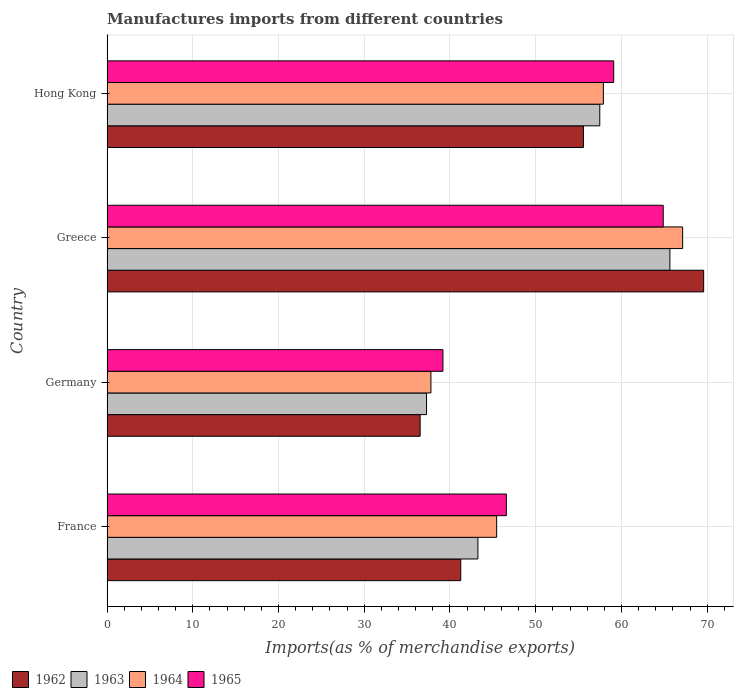How many groups of bars are there?
Make the answer very short. 4. Are the number of bars per tick equal to the number of legend labels?
Make the answer very short. Yes. How many bars are there on the 1st tick from the top?
Give a very brief answer. 4. What is the label of the 4th group of bars from the top?
Make the answer very short. France. What is the percentage of imports to different countries in 1963 in Greece?
Your answer should be very brief. 65.65. Across all countries, what is the maximum percentage of imports to different countries in 1962?
Offer a terse response. 69.58. Across all countries, what is the minimum percentage of imports to different countries in 1963?
Your answer should be very brief. 37.26. In which country was the percentage of imports to different countries in 1965 maximum?
Your response must be concise. Greece. In which country was the percentage of imports to different countries in 1965 minimum?
Your answer should be compact. Germany. What is the total percentage of imports to different countries in 1962 in the graph?
Ensure brevity in your answer.  202.92. What is the difference between the percentage of imports to different countries in 1962 in Greece and that in Hong Kong?
Offer a terse response. 14.02. What is the difference between the percentage of imports to different countries in 1962 in Greece and the percentage of imports to different countries in 1964 in France?
Make the answer very short. 24.14. What is the average percentage of imports to different countries in 1965 per country?
Provide a short and direct response. 52.43. What is the difference between the percentage of imports to different countries in 1965 and percentage of imports to different countries in 1964 in Germany?
Keep it short and to the point. 1.4. In how many countries, is the percentage of imports to different countries in 1962 greater than 2 %?
Your answer should be very brief. 4. What is the ratio of the percentage of imports to different countries in 1965 in Greece to that in Hong Kong?
Your answer should be very brief. 1.1. Is the difference between the percentage of imports to different countries in 1965 in Germany and Hong Kong greater than the difference between the percentage of imports to different countries in 1964 in Germany and Hong Kong?
Ensure brevity in your answer.  Yes. What is the difference between the highest and the second highest percentage of imports to different countries in 1963?
Give a very brief answer. 8.18. What is the difference between the highest and the lowest percentage of imports to different countries in 1964?
Your response must be concise. 29.35. In how many countries, is the percentage of imports to different countries in 1962 greater than the average percentage of imports to different countries in 1962 taken over all countries?
Your answer should be compact. 2. Is the sum of the percentage of imports to different countries in 1965 in Greece and Hong Kong greater than the maximum percentage of imports to different countries in 1962 across all countries?
Offer a very short reply. Yes. Is it the case that in every country, the sum of the percentage of imports to different countries in 1965 and percentage of imports to different countries in 1963 is greater than the sum of percentage of imports to different countries in 1964 and percentage of imports to different countries in 1962?
Provide a short and direct response. No. What does the 2nd bar from the top in Germany represents?
Make the answer very short. 1964. What does the 3rd bar from the bottom in Hong Kong represents?
Your response must be concise. 1964. Is it the case that in every country, the sum of the percentage of imports to different countries in 1965 and percentage of imports to different countries in 1963 is greater than the percentage of imports to different countries in 1964?
Your answer should be compact. Yes. How many countries are there in the graph?
Your answer should be compact. 4. What is the difference between two consecutive major ticks on the X-axis?
Provide a succinct answer. 10. Does the graph contain any zero values?
Ensure brevity in your answer.  No. Does the graph contain grids?
Your answer should be very brief. Yes. Where does the legend appear in the graph?
Keep it short and to the point. Bottom left. How many legend labels are there?
Ensure brevity in your answer.  4. How are the legend labels stacked?
Make the answer very short. Horizontal. What is the title of the graph?
Provide a succinct answer. Manufactures imports from different countries. What is the label or title of the X-axis?
Your answer should be very brief. Imports(as % of merchandise exports). What is the label or title of the Y-axis?
Provide a succinct answer. Country. What is the Imports(as % of merchandise exports) in 1962 in France?
Give a very brief answer. 41.26. What is the Imports(as % of merchandise exports) of 1963 in France?
Give a very brief answer. 43.26. What is the Imports(as % of merchandise exports) of 1964 in France?
Offer a very short reply. 45.44. What is the Imports(as % of merchandise exports) in 1965 in France?
Your answer should be compact. 46.57. What is the Imports(as % of merchandise exports) in 1962 in Germany?
Your answer should be compact. 36.52. What is the Imports(as % of merchandise exports) of 1963 in Germany?
Your answer should be very brief. 37.26. What is the Imports(as % of merchandise exports) in 1964 in Germany?
Your answer should be very brief. 37.78. What is the Imports(as % of merchandise exports) of 1965 in Germany?
Offer a terse response. 39.18. What is the Imports(as % of merchandise exports) in 1962 in Greece?
Offer a very short reply. 69.58. What is the Imports(as % of merchandise exports) of 1963 in Greece?
Keep it short and to the point. 65.65. What is the Imports(as % of merchandise exports) of 1964 in Greece?
Make the answer very short. 67.13. What is the Imports(as % of merchandise exports) in 1965 in Greece?
Your response must be concise. 64.87. What is the Imports(as % of merchandise exports) of 1962 in Hong Kong?
Your response must be concise. 55.56. What is the Imports(as % of merchandise exports) in 1963 in Hong Kong?
Ensure brevity in your answer.  57.47. What is the Imports(as % of merchandise exports) in 1964 in Hong Kong?
Your answer should be very brief. 57.89. What is the Imports(as % of merchandise exports) in 1965 in Hong Kong?
Your answer should be compact. 59.09. Across all countries, what is the maximum Imports(as % of merchandise exports) of 1962?
Provide a succinct answer. 69.58. Across all countries, what is the maximum Imports(as % of merchandise exports) in 1963?
Provide a short and direct response. 65.65. Across all countries, what is the maximum Imports(as % of merchandise exports) in 1964?
Give a very brief answer. 67.13. Across all countries, what is the maximum Imports(as % of merchandise exports) of 1965?
Give a very brief answer. 64.87. Across all countries, what is the minimum Imports(as % of merchandise exports) of 1962?
Your response must be concise. 36.52. Across all countries, what is the minimum Imports(as % of merchandise exports) in 1963?
Your answer should be compact. 37.26. Across all countries, what is the minimum Imports(as % of merchandise exports) of 1964?
Keep it short and to the point. 37.78. Across all countries, what is the minimum Imports(as % of merchandise exports) in 1965?
Make the answer very short. 39.18. What is the total Imports(as % of merchandise exports) in 1962 in the graph?
Offer a very short reply. 202.92. What is the total Imports(as % of merchandise exports) in 1963 in the graph?
Make the answer very short. 203.63. What is the total Imports(as % of merchandise exports) of 1964 in the graph?
Provide a succinct answer. 208.24. What is the total Imports(as % of merchandise exports) in 1965 in the graph?
Provide a short and direct response. 209.71. What is the difference between the Imports(as % of merchandise exports) in 1962 in France and that in Germany?
Your answer should be compact. 4.74. What is the difference between the Imports(as % of merchandise exports) of 1963 in France and that in Germany?
Provide a succinct answer. 5.99. What is the difference between the Imports(as % of merchandise exports) in 1964 in France and that in Germany?
Offer a very short reply. 7.67. What is the difference between the Imports(as % of merchandise exports) in 1965 in France and that in Germany?
Your answer should be very brief. 7.4. What is the difference between the Imports(as % of merchandise exports) of 1962 in France and that in Greece?
Make the answer very short. -28.33. What is the difference between the Imports(as % of merchandise exports) in 1963 in France and that in Greece?
Make the answer very short. -22.39. What is the difference between the Imports(as % of merchandise exports) of 1964 in France and that in Greece?
Provide a short and direct response. -21.69. What is the difference between the Imports(as % of merchandise exports) of 1965 in France and that in Greece?
Give a very brief answer. -18.29. What is the difference between the Imports(as % of merchandise exports) in 1962 in France and that in Hong Kong?
Your response must be concise. -14.31. What is the difference between the Imports(as % of merchandise exports) of 1963 in France and that in Hong Kong?
Provide a short and direct response. -14.21. What is the difference between the Imports(as % of merchandise exports) of 1964 in France and that in Hong Kong?
Your answer should be compact. -12.45. What is the difference between the Imports(as % of merchandise exports) in 1965 in France and that in Hong Kong?
Keep it short and to the point. -12.52. What is the difference between the Imports(as % of merchandise exports) of 1962 in Germany and that in Greece?
Make the answer very short. -33.06. What is the difference between the Imports(as % of merchandise exports) of 1963 in Germany and that in Greece?
Your response must be concise. -28.38. What is the difference between the Imports(as % of merchandise exports) in 1964 in Germany and that in Greece?
Provide a succinct answer. -29.35. What is the difference between the Imports(as % of merchandise exports) in 1965 in Germany and that in Greece?
Offer a very short reply. -25.69. What is the difference between the Imports(as % of merchandise exports) of 1962 in Germany and that in Hong Kong?
Provide a short and direct response. -19.04. What is the difference between the Imports(as % of merchandise exports) of 1963 in Germany and that in Hong Kong?
Give a very brief answer. -20.2. What is the difference between the Imports(as % of merchandise exports) of 1964 in Germany and that in Hong Kong?
Offer a terse response. -20.11. What is the difference between the Imports(as % of merchandise exports) of 1965 in Germany and that in Hong Kong?
Your response must be concise. -19.91. What is the difference between the Imports(as % of merchandise exports) in 1962 in Greece and that in Hong Kong?
Offer a very short reply. 14.02. What is the difference between the Imports(as % of merchandise exports) of 1963 in Greece and that in Hong Kong?
Keep it short and to the point. 8.18. What is the difference between the Imports(as % of merchandise exports) in 1964 in Greece and that in Hong Kong?
Offer a terse response. 9.24. What is the difference between the Imports(as % of merchandise exports) in 1965 in Greece and that in Hong Kong?
Offer a terse response. 5.78. What is the difference between the Imports(as % of merchandise exports) of 1962 in France and the Imports(as % of merchandise exports) of 1963 in Germany?
Provide a succinct answer. 3.99. What is the difference between the Imports(as % of merchandise exports) in 1962 in France and the Imports(as % of merchandise exports) in 1964 in Germany?
Keep it short and to the point. 3.48. What is the difference between the Imports(as % of merchandise exports) of 1962 in France and the Imports(as % of merchandise exports) of 1965 in Germany?
Provide a short and direct response. 2.08. What is the difference between the Imports(as % of merchandise exports) in 1963 in France and the Imports(as % of merchandise exports) in 1964 in Germany?
Offer a very short reply. 5.48. What is the difference between the Imports(as % of merchandise exports) of 1963 in France and the Imports(as % of merchandise exports) of 1965 in Germany?
Provide a short and direct response. 4.08. What is the difference between the Imports(as % of merchandise exports) in 1964 in France and the Imports(as % of merchandise exports) in 1965 in Germany?
Provide a short and direct response. 6.27. What is the difference between the Imports(as % of merchandise exports) of 1962 in France and the Imports(as % of merchandise exports) of 1963 in Greece?
Provide a succinct answer. -24.39. What is the difference between the Imports(as % of merchandise exports) of 1962 in France and the Imports(as % of merchandise exports) of 1964 in Greece?
Make the answer very short. -25.87. What is the difference between the Imports(as % of merchandise exports) in 1962 in France and the Imports(as % of merchandise exports) in 1965 in Greece?
Keep it short and to the point. -23.61. What is the difference between the Imports(as % of merchandise exports) of 1963 in France and the Imports(as % of merchandise exports) of 1964 in Greece?
Provide a short and direct response. -23.87. What is the difference between the Imports(as % of merchandise exports) of 1963 in France and the Imports(as % of merchandise exports) of 1965 in Greece?
Keep it short and to the point. -21.61. What is the difference between the Imports(as % of merchandise exports) in 1964 in France and the Imports(as % of merchandise exports) in 1965 in Greece?
Keep it short and to the point. -19.43. What is the difference between the Imports(as % of merchandise exports) of 1962 in France and the Imports(as % of merchandise exports) of 1963 in Hong Kong?
Your answer should be very brief. -16.21. What is the difference between the Imports(as % of merchandise exports) of 1962 in France and the Imports(as % of merchandise exports) of 1964 in Hong Kong?
Offer a terse response. -16.63. What is the difference between the Imports(as % of merchandise exports) in 1962 in France and the Imports(as % of merchandise exports) in 1965 in Hong Kong?
Your answer should be very brief. -17.83. What is the difference between the Imports(as % of merchandise exports) in 1963 in France and the Imports(as % of merchandise exports) in 1964 in Hong Kong?
Your answer should be very brief. -14.63. What is the difference between the Imports(as % of merchandise exports) of 1963 in France and the Imports(as % of merchandise exports) of 1965 in Hong Kong?
Ensure brevity in your answer.  -15.83. What is the difference between the Imports(as % of merchandise exports) of 1964 in France and the Imports(as % of merchandise exports) of 1965 in Hong Kong?
Make the answer very short. -13.65. What is the difference between the Imports(as % of merchandise exports) of 1962 in Germany and the Imports(as % of merchandise exports) of 1963 in Greece?
Keep it short and to the point. -29.13. What is the difference between the Imports(as % of merchandise exports) in 1962 in Germany and the Imports(as % of merchandise exports) in 1964 in Greece?
Your answer should be compact. -30.61. What is the difference between the Imports(as % of merchandise exports) of 1962 in Germany and the Imports(as % of merchandise exports) of 1965 in Greece?
Your response must be concise. -28.35. What is the difference between the Imports(as % of merchandise exports) in 1963 in Germany and the Imports(as % of merchandise exports) in 1964 in Greece?
Make the answer very short. -29.87. What is the difference between the Imports(as % of merchandise exports) in 1963 in Germany and the Imports(as % of merchandise exports) in 1965 in Greece?
Make the answer very short. -27.6. What is the difference between the Imports(as % of merchandise exports) in 1964 in Germany and the Imports(as % of merchandise exports) in 1965 in Greece?
Provide a succinct answer. -27.09. What is the difference between the Imports(as % of merchandise exports) in 1962 in Germany and the Imports(as % of merchandise exports) in 1963 in Hong Kong?
Your response must be concise. -20.95. What is the difference between the Imports(as % of merchandise exports) in 1962 in Germany and the Imports(as % of merchandise exports) in 1964 in Hong Kong?
Make the answer very short. -21.37. What is the difference between the Imports(as % of merchandise exports) of 1962 in Germany and the Imports(as % of merchandise exports) of 1965 in Hong Kong?
Keep it short and to the point. -22.57. What is the difference between the Imports(as % of merchandise exports) of 1963 in Germany and the Imports(as % of merchandise exports) of 1964 in Hong Kong?
Your response must be concise. -20.62. What is the difference between the Imports(as % of merchandise exports) of 1963 in Germany and the Imports(as % of merchandise exports) of 1965 in Hong Kong?
Provide a short and direct response. -21.83. What is the difference between the Imports(as % of merchandise exports) of 1964 in Germany and the Imports(as % of merchandise exports) of 1965 in Hong Kong?
Provide a succinct answer. -21.31. What is the difference between the Imports(as % of merchandise exports) of 1962 in Greece and the Imports(as % of merchandise exports) of 1963 in Hong Kong?
Your answer should be very brief. 12.12. What is the difference between the Imports(as % of merchandise exports) in 1962 in Greece and the Imports(as % of merchandise exports) in 1964 in Hong Kong?
Provide a succinct answer. 11.7. What is the difference between the Imports(as % of merchandise exports) in 1962 in Greece and the Imports(as % of merchandise exports) in 1965 in Hong Kong?
Provide a succinct answer. 10.49. What is the difference between the Imports(as % of merchandise exports) in 1963 in Greece and the Imports(as % of merchandise exports) in 1964 in Hong Kong?
Your response must be concise. 7.76. What is the difference between the Imports(as % of merchandise exports) in 1963 in Greece and the Imports(as % of merchandise exports) in 1965 in Hong Kong?
Your answer should be compact. 6.56. What is the difference between the Imports(as % of merchandise exports) in 1964 in Greece and the Imports(as % of merchandise exports) in 1965 in Hong Kong?
Make the answer very short. 8.04. What is the average Imports(as % of merchandise exports) of 1962 per country?
Give a very brief answer. 50.73. What is the average Imports(as % of merchandise exports) of 1963 per country?
Make the answer very short. 50.91. What is the average Imports(as % of merchandise exports) of 1964 per country?
Your response must be concise. 52.06. What is the average Imports(as % of merchandise exports) of 1965 per country?
Your response must be concise. 52.43. What is the difference between the Imports(as % of merchandise exports) in 1962 and Imports(as % of merchandise exports) in 1963 in France?
Keep it short and to the point. -2. What is the difference between the Imports(as % of merchandise exports) in 1962 and Imports(as % of merchandise exports) in 1964 in France?
Your answer should be compact. -4.19. What is the difference between the Imports(as % of merchandise exports) in 1962 and Imports(as % of merchandise exports) in 1965 in France?
Your response must be concise. -5.32. What is the difference between the Imports(as % of merchandise exports) in 1963 and Imports(as % of merchandise exports) in 1964 in France?
Ensure brevity in your answer.  -2.19. What is the difference between the Imports(as % of merchandise exports) in 1963 and Imports(as % of merchandise exports) in 1965 in France?
Offer a terse response. -3.32. What is the difference between the Imports(as % of merchandise exports) of 1964 and Imports(as % of merchandise exports) of 1965 in France?
Keep it short and to the point. -1.13. What is the difference between the Imports(as % of merchandise exports) of 1962 and Imports(as % of merchandise exports) of 1963 in Germany?
Provide a succinct answer. -0.75. What is the difference between the Imports(as % of merchandise exports) of 1962 and Imports(as % of merchandise exports) of 1964 in Germany?
Offer a very short reply. -1.26. What is the difference between the Imports(as % of merchandise exports) in 1962 and Imports(as % of merchandise exports) in 1965 in Germany?
Your answer should be compact. -2.66. What is the difference between the Imports(as % of merchandise exports) in 1963 and Imports(as % of merchandise exports) in 1964 in Germany?
Give a very brief answer. -0.51. What is the difference between the Imports(as % of merchandise exports) in 1963 and Imports(as % of merchandise exports) in 1965 in Germany?
Offer a very short reply. -1.91. What is the difference between the Imports(as % of merchandise exports) of 1964 and Imports(as % of merchandise exports) of 1965 in Germany?
Provide a succinct answer. -1.4. What is the difference between the Imports(as % of merchandise exports) of 1962 and Imports(as % of merchandise exports) of 1963 in Greece?
Keep it short and to the point. 3.94. What is the difference between the Imports(as % of merchandise exports) in 1962 and Imports(as % of merchandise exports) in 1964 in Greece?
Keep it short and to the point. 2.45. What is the difference between the Imports(as % of merchandise exports) in 1962 and Imports(as % of merchandise exports) in 1965 in Greece?
Offer a terse response. 4.72. What is the difference between the Imports(as % of merchandise exports) of 1963 and Imports(as % of merchandise exports) of 1964 in Greece?
Your response must be concise. -1.48. What is the difference between the Imports(as % of merchandise exports) of 1963 and Imports(as % of merchandise exports) of 1965 in Greece?
Give a very brief answer. 0.78. What is the difference between the Imports(as % of merchandise exports) of 1964 and Imports(as % of merchandise exports) of 1965 in Greece?
Your answer should be compact. 2.26. What is the difference between the Imports(as % of merchandise exports) of 1962 and Imports(as % of merchandise exports) of 1963 in Hong Kong?
Your answer should be very brief. -1.91. What is the difference between the Imports(as % of merchandise exports) of 1962 and Imports(as % of merchandise exports) of 1964 in Hong Kong?
Offer a terse response. -2.33. What is the difference between the Imports(as % of merchandise exports) in 1962 and Imports(as % of merchandise exports) in 1965 in Hong Kong?
Offer a very short reply. -3.53. What is the difference between the Imports(as % of merchandise exports) of 1963 and Imports(as % of merchandise exports) of 1964 in Hong Kong?
Make the answer very short. -0.42. What is the difference between the Imports(as % of merchandise exports) in 1963 and Imports(as % of merchandise exports) in 1965 in Hong Kong?
Ensure brevity in your answer.  -1.62. What is the difference between the Imports(as % of merchandise exports) in 1964 and Imports(as % of merchandise exports) in 1965 in Hong Kong?
Your answer should be compact. -1.2. What is the ratio of the Imports(as % of merchandise exports) of 1962 in France to that in Germany?
Keep it short and to the point. 1.13. What is the ratio of the Imports(as % of merchandise exports) of 1963 in France to that in Germany?
Your answer should be compact. 1.16. What is the ratio of the Imports(as % of merchandise exports) in 1964 in France to that in Germany?
Make the answer very short. 1.2. What is the ratio of the Imports(as % of merchandise exports) of 1965 in France to that in Germany?
Ensure brevity in your answer.  1.19. What is the ratio of the Imports(as % of merchandise exports) in 1962 in France to that in Greece?
Give a very brief answer. 0.59. What is the ratio of the Imports(as % of merchandise exports) in 1963 in France to that in Greece?
Ensure brevity in your answer.  0.66. What is the ratio of the Imports(as % of merchandise exports) in 1964 in France to that in Greece?
Offer a very short reply. 0.68. What is the ratio of the Imports(as % of merchandise exports) of 1965 in France to that in Greece?
Make the answer very short. 0.72. What is the ratio of the Imports(as % of merchandise exports) in 1962 in France to that in Hong Kong?
Your answer should be compact. 0.74. What is the ratio of the Imports(as % of merchandise exports) of 1963 in France to that in Hong Kong?
Make the answer very short. 0.75. What is the ratio of the Imports(as % of merchandise exports) in 1964 in France to that in Hong Kong?
Ensure brevity in your answer.  0.79. What is the ratio of the Imports(as % of merchandise exports) of 1965 in France to that in Hong Kong?
Give a very brief answer. 0.79. What is the ratio of the Imports(as % of merchandise exports) in 1962 in Germany to that in Greece?
Make the answer very short. 0.52. What is the ratio of the Imports(as % of merchandise exports) of 1963 in Germany to that in Greece?
Ensure brevity in your answer.  0.57. What is the ratio of the Imports(as % of merchandise exports) in 1964 in Germany to that in Greece?
Keep it short and to the point. 0.56. What is the ratio of the Imports(as % of merchandise exports) in 1965 in Germany to that in Greece?
Offer a terse response. 0.6. What is the ratio of the Imports(as % of merchandise exports) in 1962 in Germany to that in Hong Kong?
Ensure brevity in your answer.  0.66. What is the ratio of the Imports(as % of merchandise exports) in 1963 in Germany to that in Hong Kong?
Offer a very short reply. 0.65. What is the ratio of the Imports(as % of merchandise exports) of 1964 in Germany to that in Hong Kong?
Provide a succinct answer. 0.65. What is the ratio of the Imports(as % of merchandise exports) of 1965 in Germany to that in Hong Kong?
Give a very brief answer. 0.66. What is the ratio of the Imports(as % of merchandise exports) of 1962 in Greece to that in Hong Kong?
Your answer should be very brief. 1.25. What is the ratio of the Imports(as % of merchandise exports) of 1963 in Greece to that in Hong Kong?
Ensure brevity in your answer.  1.14. What is the ratio of the Imports(as % of merchandise exports) of 1964 in Greece to that in Hong Kong?
Your answer should be compact. 1.16. What is the ratio of the Imports(as % of merchandise exports) of 1965 in Greece to that in Hong Kong?
Give a very brief answer. 1.1. What is the difference between the highest and the second highest Imports(as % of merchandise exports) in 1962?
Your response must be concise. 14.02. What is the difference between the highest and the second highest Imports(as % of merchandise exports) in 1963?
Provide a succinct answer. 8.18. What is the difference between the highest and the second highest Imports(as % of merchandise exports) in 1964?
Provide a short and direct response. 9.24. What is the difference between the highest and the second highest Imports(as % of merchandise exports) in 1965?
Your response must be concise. 5.78. What is the difference between the highest and the lowest Imports(as % of merchandise exports) of 1962?
Your answer should be very brief. 33.06. What is the difference between the highest and the lowest Imports(as % of merchandise exports) in 1963?
Provide a short and direct response. 28.38. What is the difference between the highest and the lowest Imports(as % of merchandise exports) of 1964?
Give a very brief answer. 29.35. What is the difference between the highest and the lowest Imports(as % of merchandise exports) of 1965?
Make the answer very short. 25.69. 